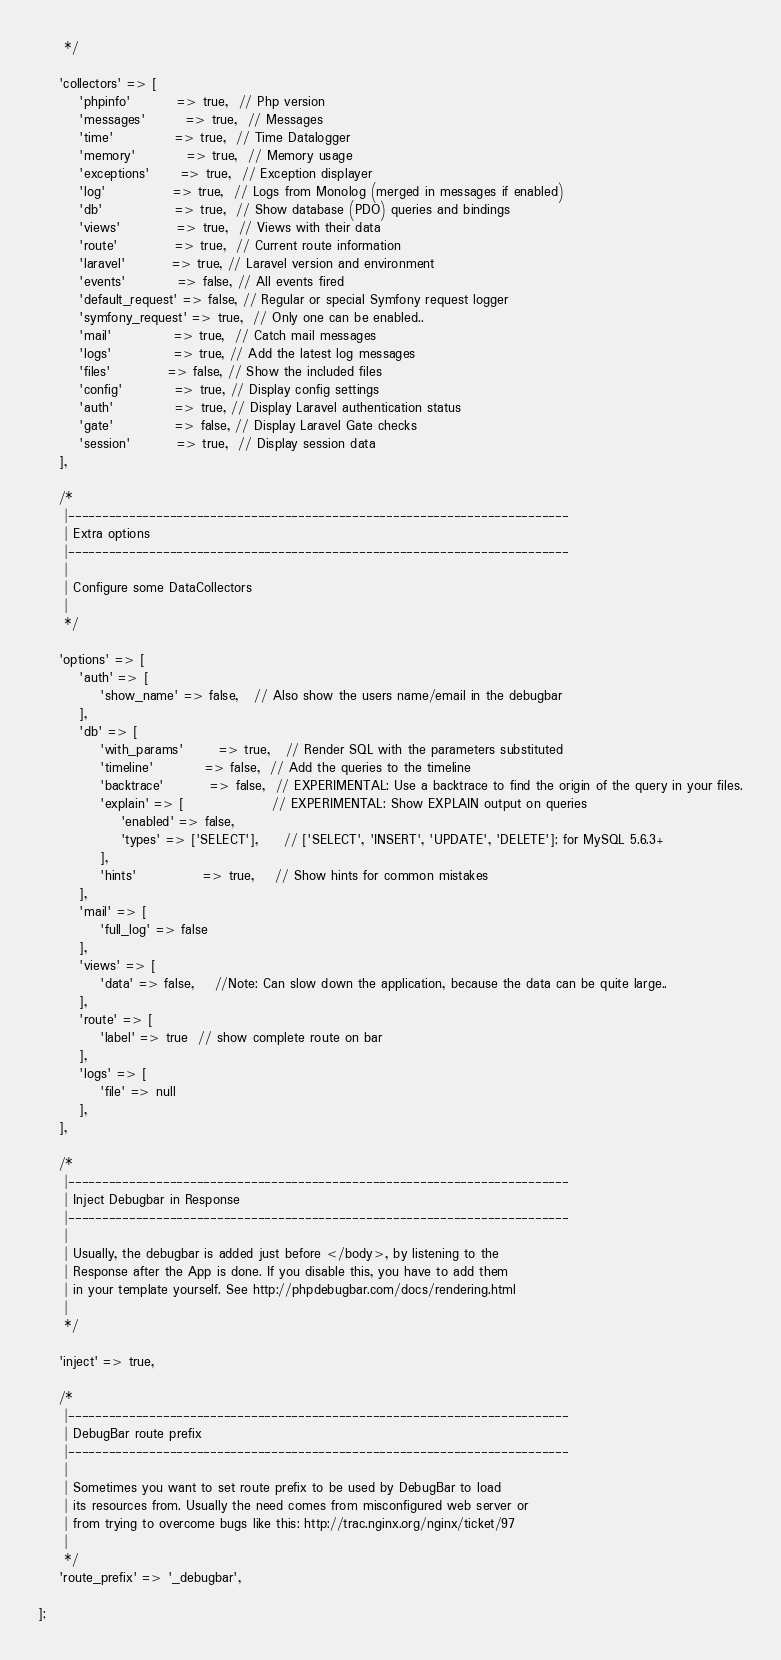<code> <loc_0><loc_0><loc_500><loc_500><_PHP_>     */

    'collectors' => [
        'phpinfo'         => true,  // Php version
        'messages'        => true,  // Messages
        'time'            => true,  // Time Datalogger
        'memory'          => true,  // Memory usage
        'exceptions'      => true,  // Exception displayer
        'log'             => true,  // Logs from Monolog (merged in messages if enabled)
        'db'              => true,  // Show database (PDO) queries and bindings
        'views'           => true,  // Views with their data
        'route'           => true,  // Current route information
        'laravel'         => true, // Laravel version and environment
        'events'          => false, // All events fired
        'default_request' => false, // Regular or special Symfony request logger
        'symfony_request' => true,  // Only one can be enabled..
        'mail'            => true,  // Catch mail messages
        'logs'            => true, // Add the latest log messages
        'files'           => false, // Show the included files
        'config'          => true, // Display config settings
        'auth'            => true, // Display Laravel authentication status
        'gate'            => false, // Display Laravel Gate checks
        'session'         => true,  // Display session data
    ],

    /*
     |--------------------------------------------------------------------------
     | Extra options
     |--------------------------------------------------------------------------
     |
     | Configure some DataCollectors
     |
     */

    'options' => [
        'auth' => [
            'show_name' => false,   // Also show the users name/email in the debugbar
        ],
        'db' => [
            'with_params'       => true,   // Render SQL with the parameters substituted
            'timeline'          => false,  // Add the queries to the timeline
            'backtrace'         => false,  // EXPERIMENTAL: Use a backtrace to find the origin of the query in your files.
            'explain' => [                 // EXPERIMENTAL: Show EXPLAIN output on queries
                'enabled' => false,
                'types' => ['SELECT'],     // ['SELECT', 'INSERT', 'UPDATE', 'DELETE']; for MySQL 5.6.3+
            ],
            'hints'             => true,    // Show hints for common mistakes
        ],
        'mail' => [
            'full_log' => false
        ],
        'views' => [
            'data' => false,    //Note: Can slow down the application, because the data can be quite large..
        ],
        'route' => [
            'label' => true  // show complete route on bar
        ],
        'logs' => [
            'file' => null
        ],
    ],

    /*
     |--------------------------------------------------------------------------
     | Inject Debugbar in Response
     |--------------------------------------------------------------------------
     |
     | Usually, the debugbar is added just before </body>, by listening to the
     | Response after the App is done. If you disable this, you have to add them
     | in your template yourself. See http://phpdebugbar.com/docs/rendering.html
     |
     */

    'inject' => true,

    /*
     |--------------------------------------------------------------------------
     | DebugBar route prefix
     |--------------------------------------------------------------------------
     |
     | Sometimes you want to set route prefix to be used by DebugBar to load
     | its resources from. Usually the need comes from misconfigured web server or
     | from trying to overcome bugs like this: http://trac.nginx.org/nginx/ticket/97
     |
     */
    'route_prefix' => '_debugbar',

];
</code> 